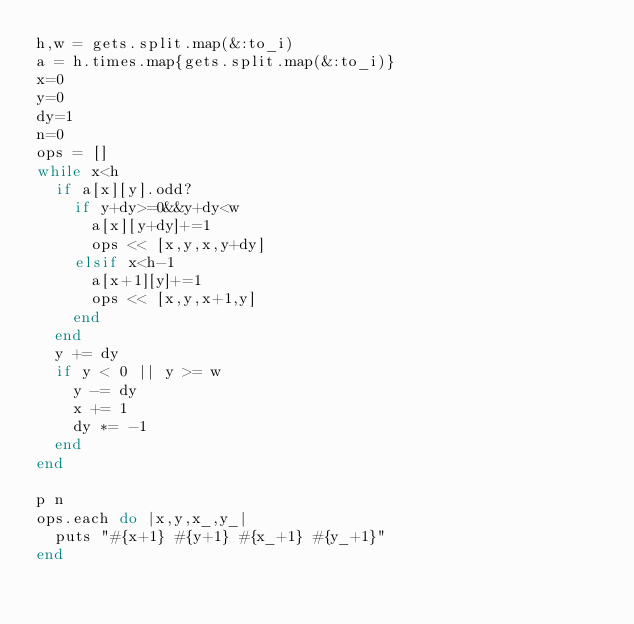Convert code to text. <code><loc_0><loc_0><loc_500><loc_500><_Ruby_>h,w = gets.split.map(&:to_i)
a = h.times.map{gets.split.map(&:to_i)}
x=0
y=0
dy=1
n=0
ops = []
while x<h
  if a[x][y].odd?
    if y+dy>=0&&y+dy<w
      a[x][y+dy]+=1
      ops << [x,y,x,y+dy]
    elsif x<h-1
      a[x+1][y]+=1
      ops << [x,y,x+1,y]
    end
  end
  y += dy
  if y < 0 || y >= w
    y -= dy
    x += 1
    dy *= -1
  end
end

p n
ops.each do |x,y,x_,y_|
  puts "#{x+1} #{y+1} #{x_+1} #{y_+1}"
end
</code> 